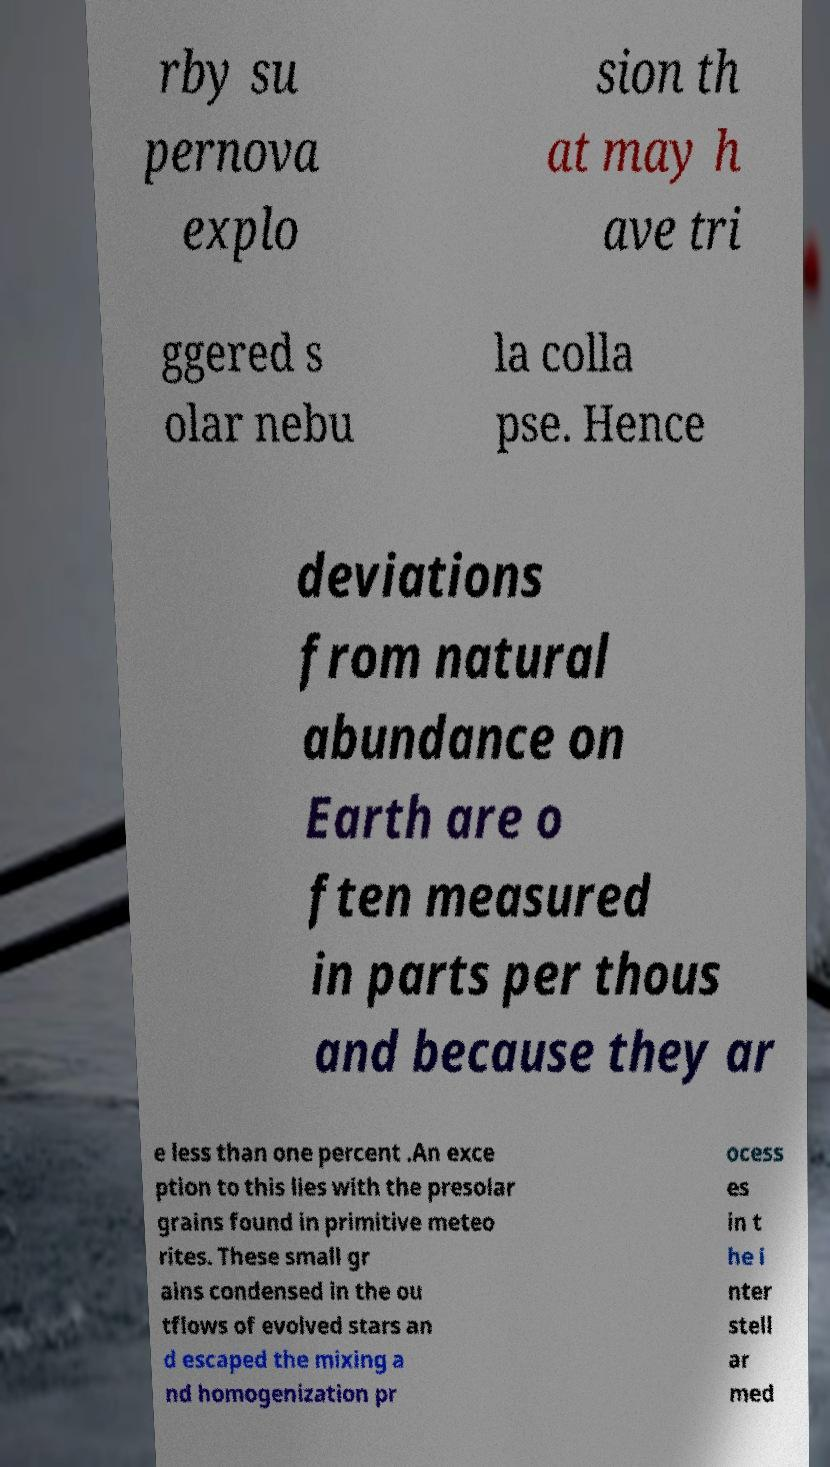There's text embedded in this image that I need extracted. Can you transcribe it verbatim? rby su pernova explo sion th at may h ave tri ggered s olar nebu la colla pse. Hence deviations from natural abundance on Earth are o ften measured in parts per thous and because they ar e less than one percent .An exce ption to this lies with the presolar grains found in primitive meteo rites. These small gr ains condensed in the ou tflows of evolved stars an d escaped the mixing a nd homogenization pr ocess es in t he i nter stell ar med 